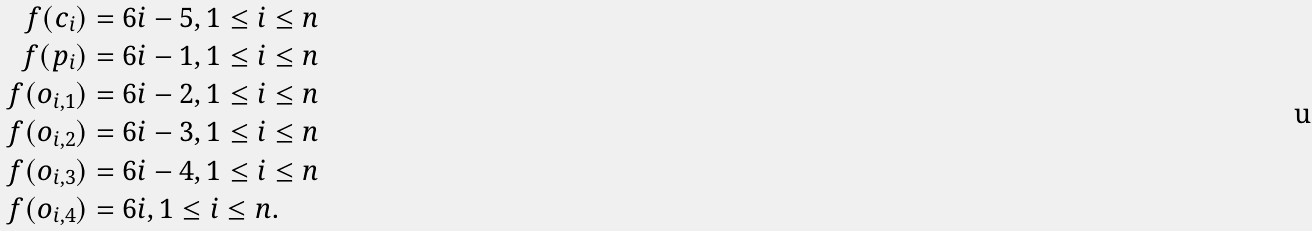Convert formula to latex. <formula><loc_0><loc_0><loc_500><loc_500>f ( c _ { i } ) & = 6 i - 5 , 1 \leq i \leq n \\ f ( p _ { i } ) & = 6 i - 1 , 1 \leq i \leq n \\ f ( o _ { i , 1 } ) & = 6 i - 2 , 1 \leq i \leq n \\ f ( o _ { i , 2 } ) & = 6 i - 3 , 1 \leq i \leq n \\ f ( o _ { i , 3 } ) & = 6 i - 4 , 1 \leq i \leq n \\ f ( o _ { i , 4 } ) & = 6 i , 1 \leq i \leq n .</formula> 